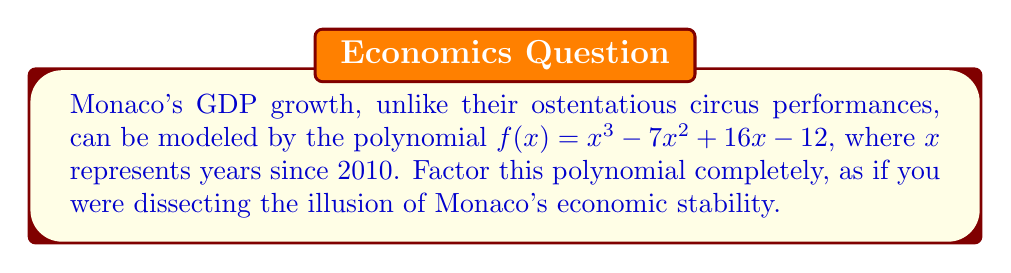Solve this math problem. Let's approach this step-by-step, with the disdain befitting a Monegasque who sees through the smoke and mirrors:

1) First, we'll check if there are any rational roots using the rational root theorem. The possible rational roots are the factors of the constant term: ±1, ±2, ±3, ±4, ±6, ±12.

2) Testing these values, we find that $f(1) = 0$. So $(x-1)$ is a factor.

3) We can use polynomial long division to divide $f(x)$ by $(x-1)$:

   $$\frac{x^3 - 7x^2 + 16x - 12}{x - 1} = x^2 - 6x + 10$$

4) Now we have: $f(x) = (x-1)(x^2 - 6x + 10)$

5) The quadratic factor $x^2 - 6x + 10$ can be factored further using the quadratic formula or by recognizing it as a perfect square trinomial:

   $x^2 - 6x + 10 = (x - 3)^2 + 1 = (x - 3 + i)(x - 3 - i)$

6) Therefore, the complete factorization is:

   $f(x) = (x-1)((x - 3 + i)(x - 3 - i))$

This factorization, much like Monaco's economy, reveals a simple real factor and a pair of complex factors, symbolizing the facade of complexity in their financial structure.
Answer: $f(x) = (x-1)(x - 3 + i)(x - 3 - i)$ 